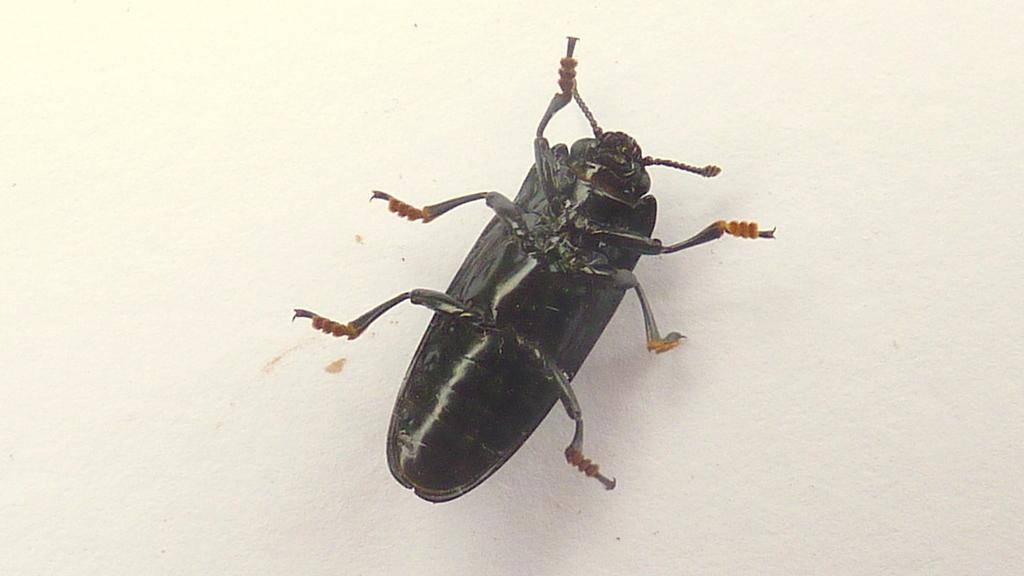What type of creature can be seen in the image? There is an insect in the image. What is the insect's location in the image? The insect is on a white surface. What type of knowledge does the robin possess in the image? There is no robin present in the image, so it is not possible to determine what knowledge it might possess. 